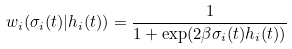<formula> <loc_0><loc_0><loc_500><loc_500>w _ { i } ( \sigma _ { i } ( t ) | h _ { i } ( t ) ) = \frac { 1 } { 1 + \exp ( 2 \beta \sigma _ { i } ( t ) h _ { i } ( t ) ) }</formula> 